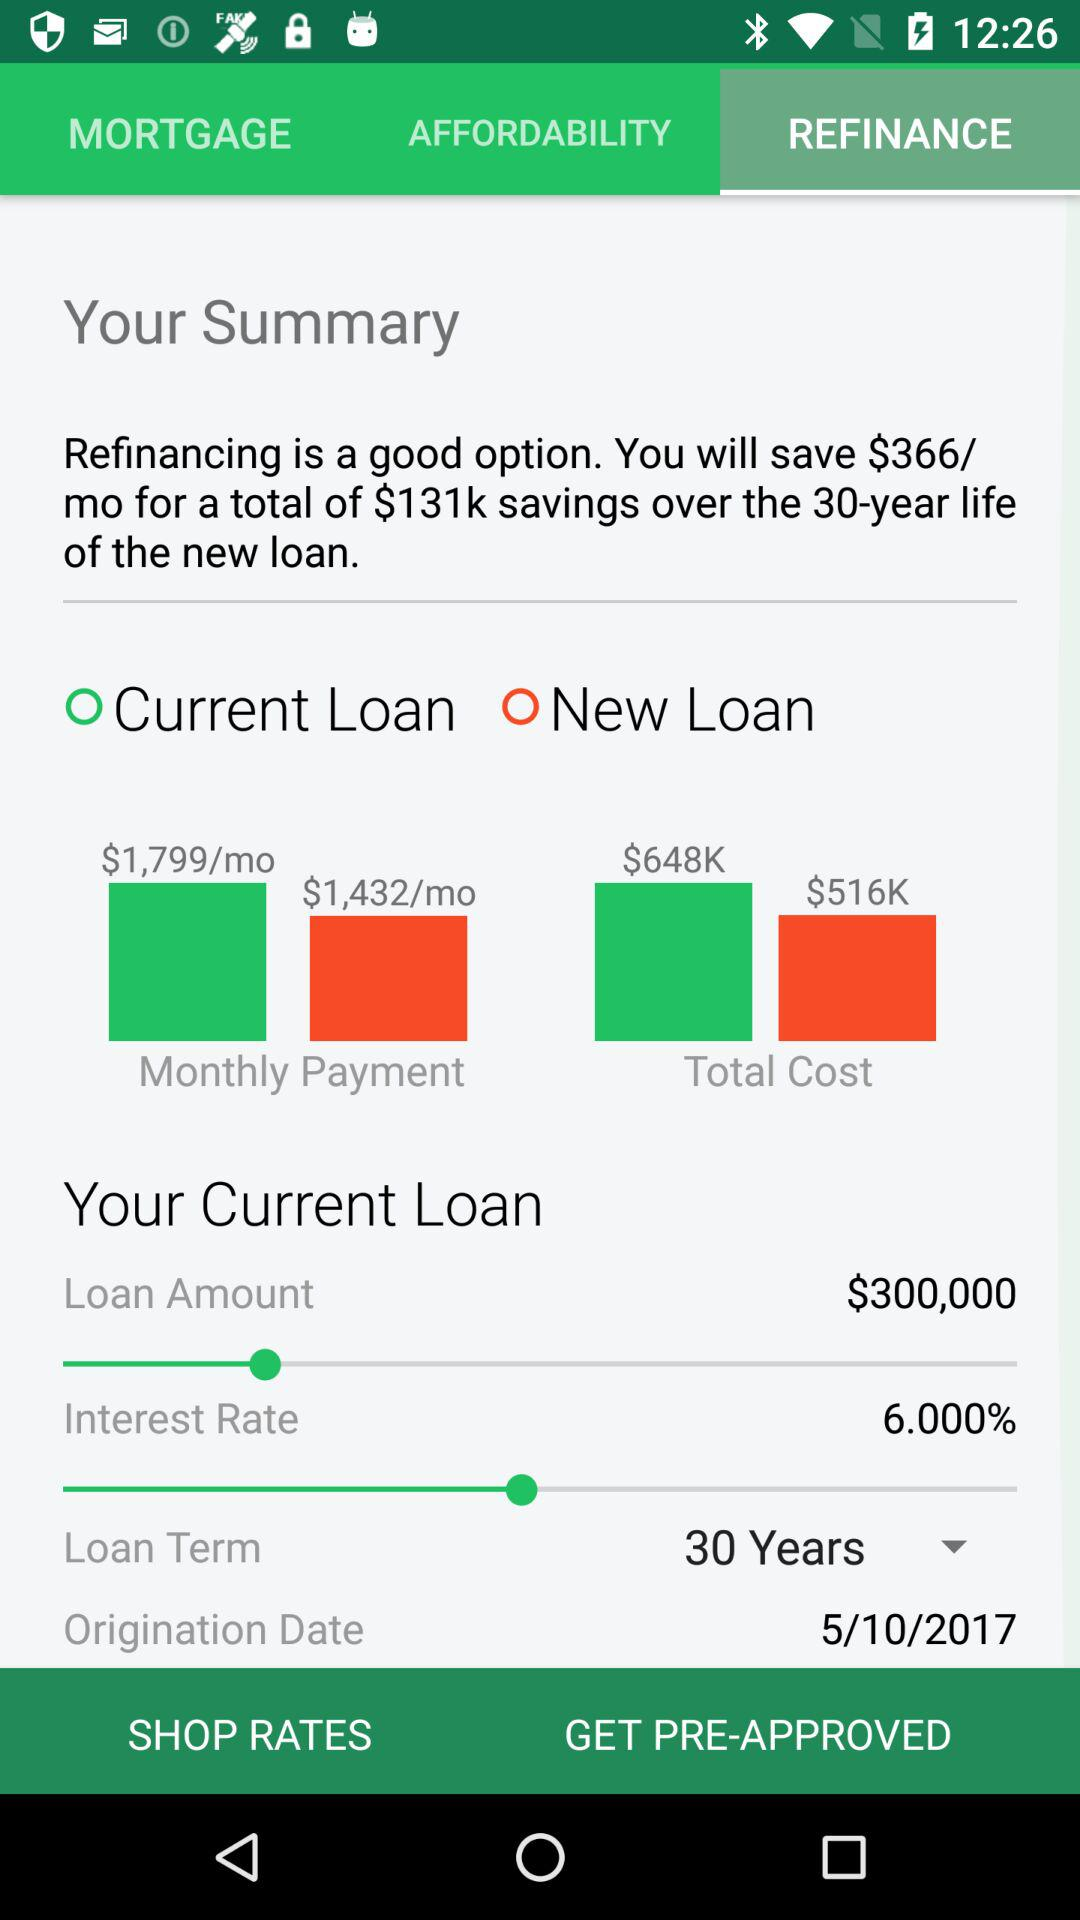How much more is the current loan payment than the new loan payment?
Answer the question using a single word or phrase. $367 